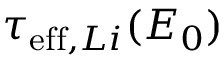Convert formula to latex. <formula><loc_0><loc_0><loc_500><loc_500>\tau _ { e f f , L i } ( E _ { 0 } )</formula> 